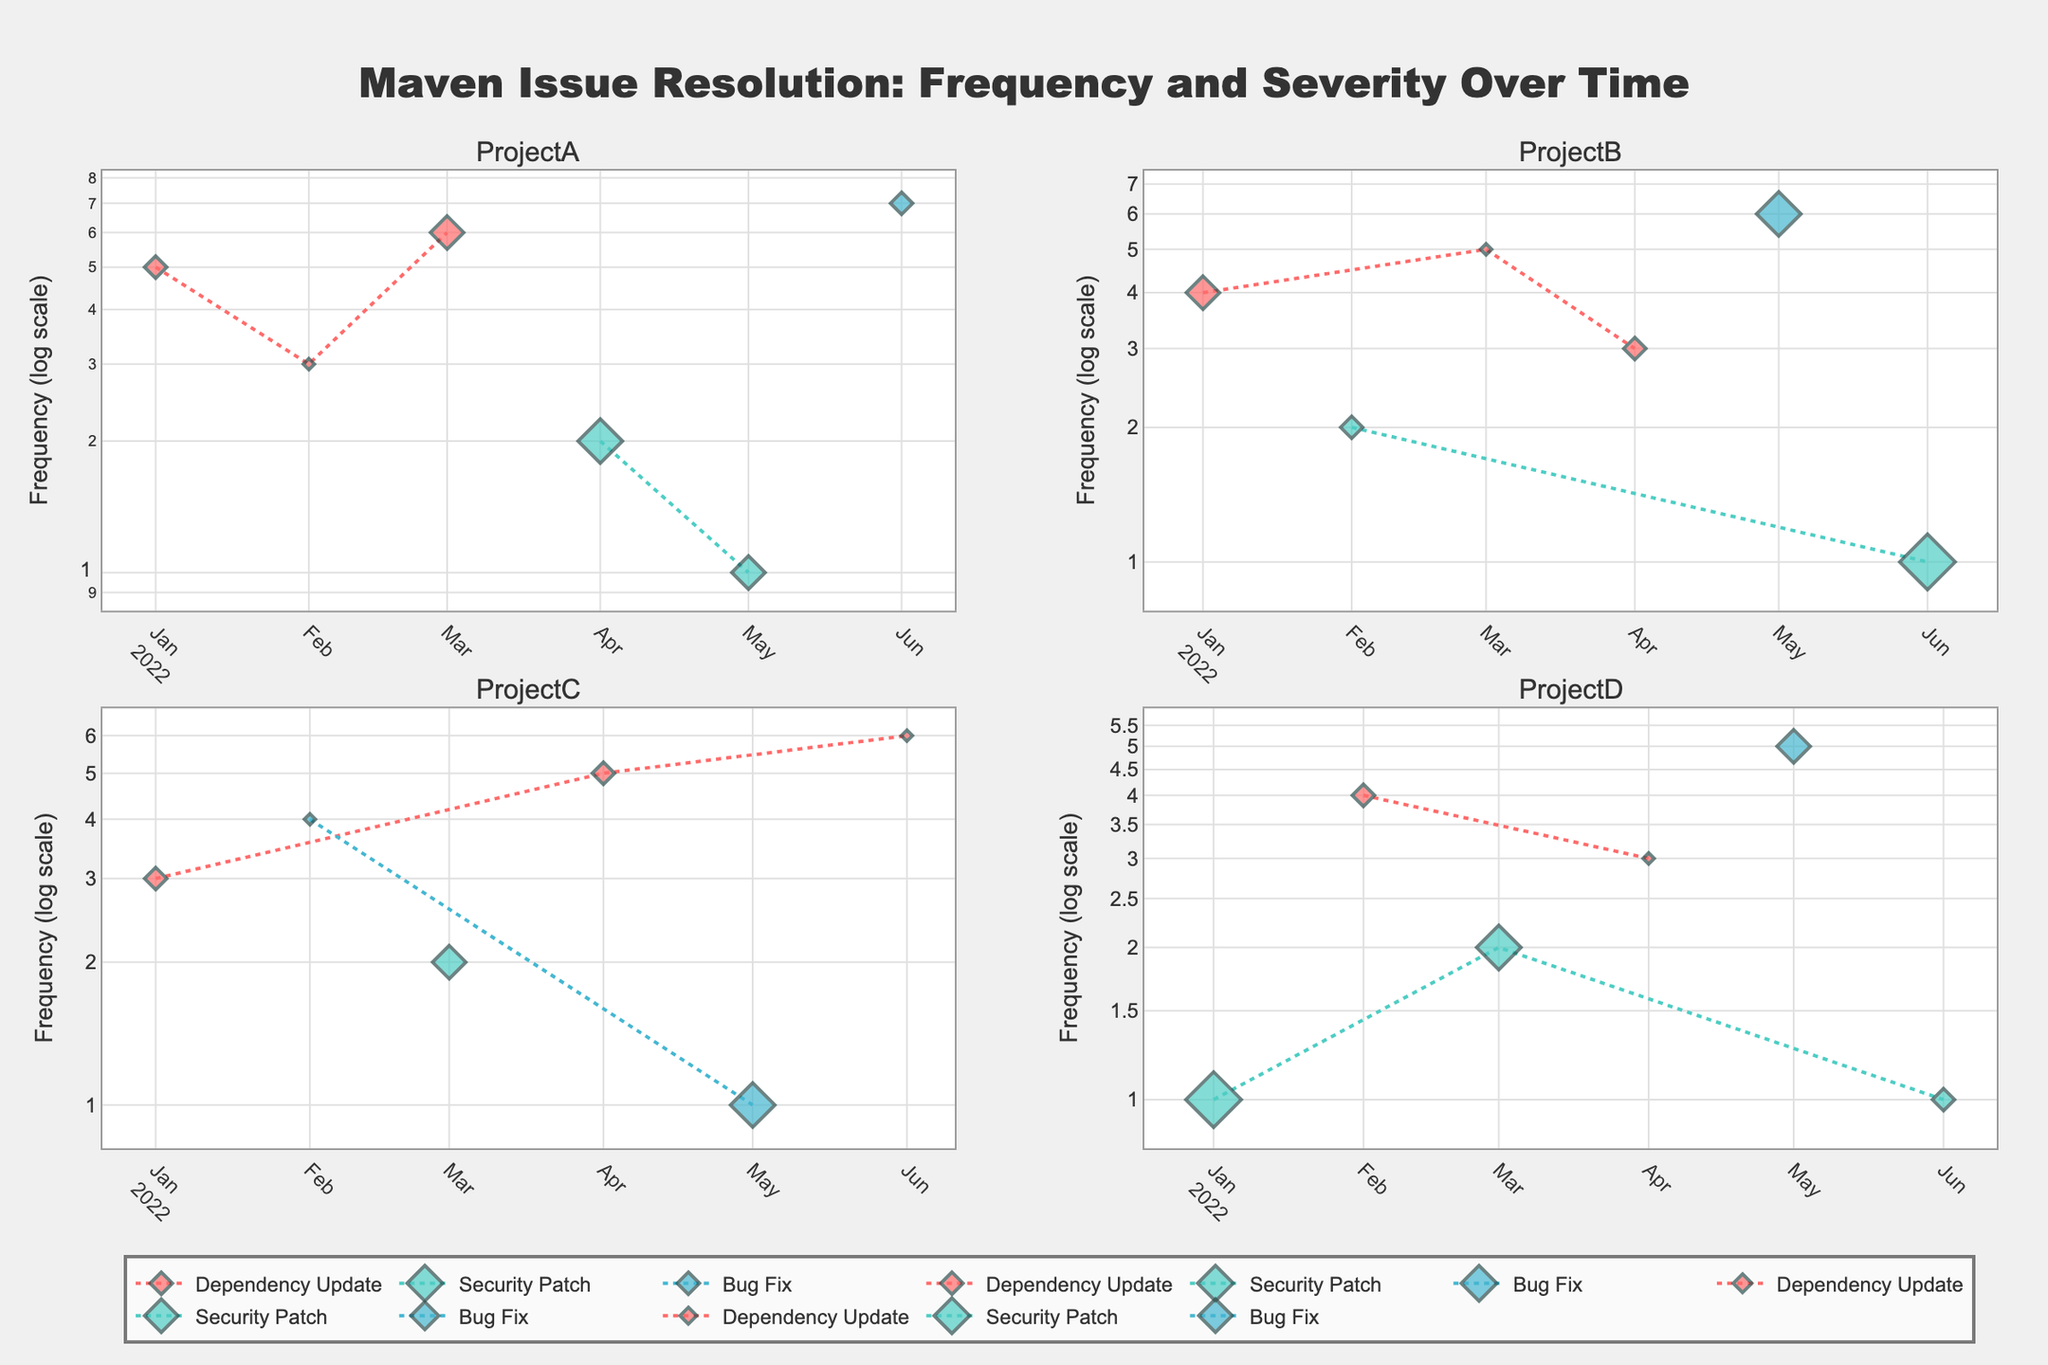what is the title of the figure? The title of the figure is shown at the top-center and reads "Maven Issue Resolution: Frequency and Severity Over Time".
Answer: Maven Issue Resolution: Frequency and Severity Over Time What does the vertical axis represent in the subplots? The vertical axis in each subplot represents the Frequency of issues resolved, and it is on a log scale.
Answer: Frequency (log scale) What are the colors used to differentiate the types of issues? Three colors are used: red for "Dependency Update", green for "Security Patch", and blue for "Bug Fix".
Answer: Red, Green, Blue Which project had the highest frequency of "Bug Fix" issues resolved in June 2022? In June 2022, Project A had the highest frequency of "Bug Fix" issues resolved at 7, as indicated by the height of the respective data point in the top-left subplot.
Answer: Project A How many different types of issues are displayed in the figure? There are three different types of issues displayed in the figure: "Dependency Update", "Security Patch", and "Bug Fix".
Answer: Three For Project B, what was the frequency of "Dependency Update" issues resolved in March 2022? The point for March 2022 in the Project B subplot shows the frequency of "Dependency Update" as 5, as denoted by the red data point in the bottom-left subplot.
Answer: 5 Which project had the lowest severity and what type of issue was it in February 2022? In February 2022, Project A had the lowest severity for a "Dependency Update" issue with a severity of 1, shown as the smallest marker in the top-left subplot.
Answer: Project A, Dependency Update How does the severity of "Security Patch" issues in Project D compare between January 2022 and June 2022? In January 2022, the severity of "Security Patch" in Project D was 5, while in June 2022, it was 2. This comparison shows the severity decreased from January to June, as seen by the relative size of the markers in the Project D subplot.
Answer: Decreased What is the overall trend of "Dependency Update" issue frequency in Project C? The frequency of "Dependency Update" issues in Project C shows an increasing trend over time, starting at 3 in January and reaching 6 in June, as indicated by the upward movement of red markers in the top-right subplot.
Answer: Increasing Which project shows more variability in the frequency of "Security Patch" issues? Project A shows more variability with frequencies ranging from 1 to 4, compared to Project D where the frequency remains low at 1 or 2, observable in the vertical distance between the green markers in the respective subplots.
Answer: Project A 